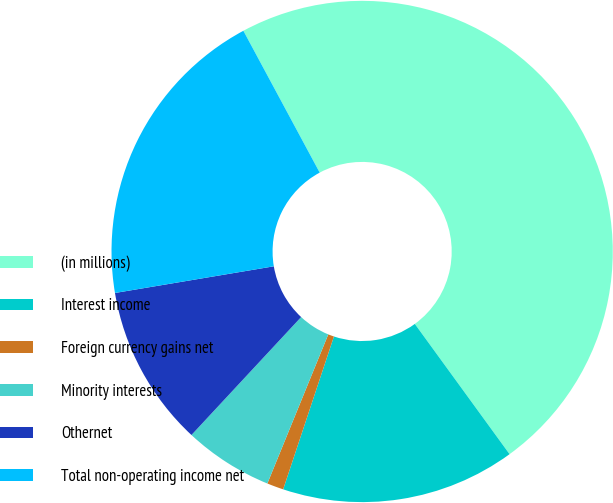<chart> <loc_0><loc_0><loc_500><loc_500><pie_chart><fcel>(in millions)<fcel>Interest income<fcel>Foreign currency gains net<fcel>Minority interests<fcel>Othernet<fcel>Total non-operating income net<nl><fcel>47.85%<fcel>15.11%<fcel>1.07%<fcel>5.75%<fcel>10.43%<fcel>19.79%<nl></chart> 